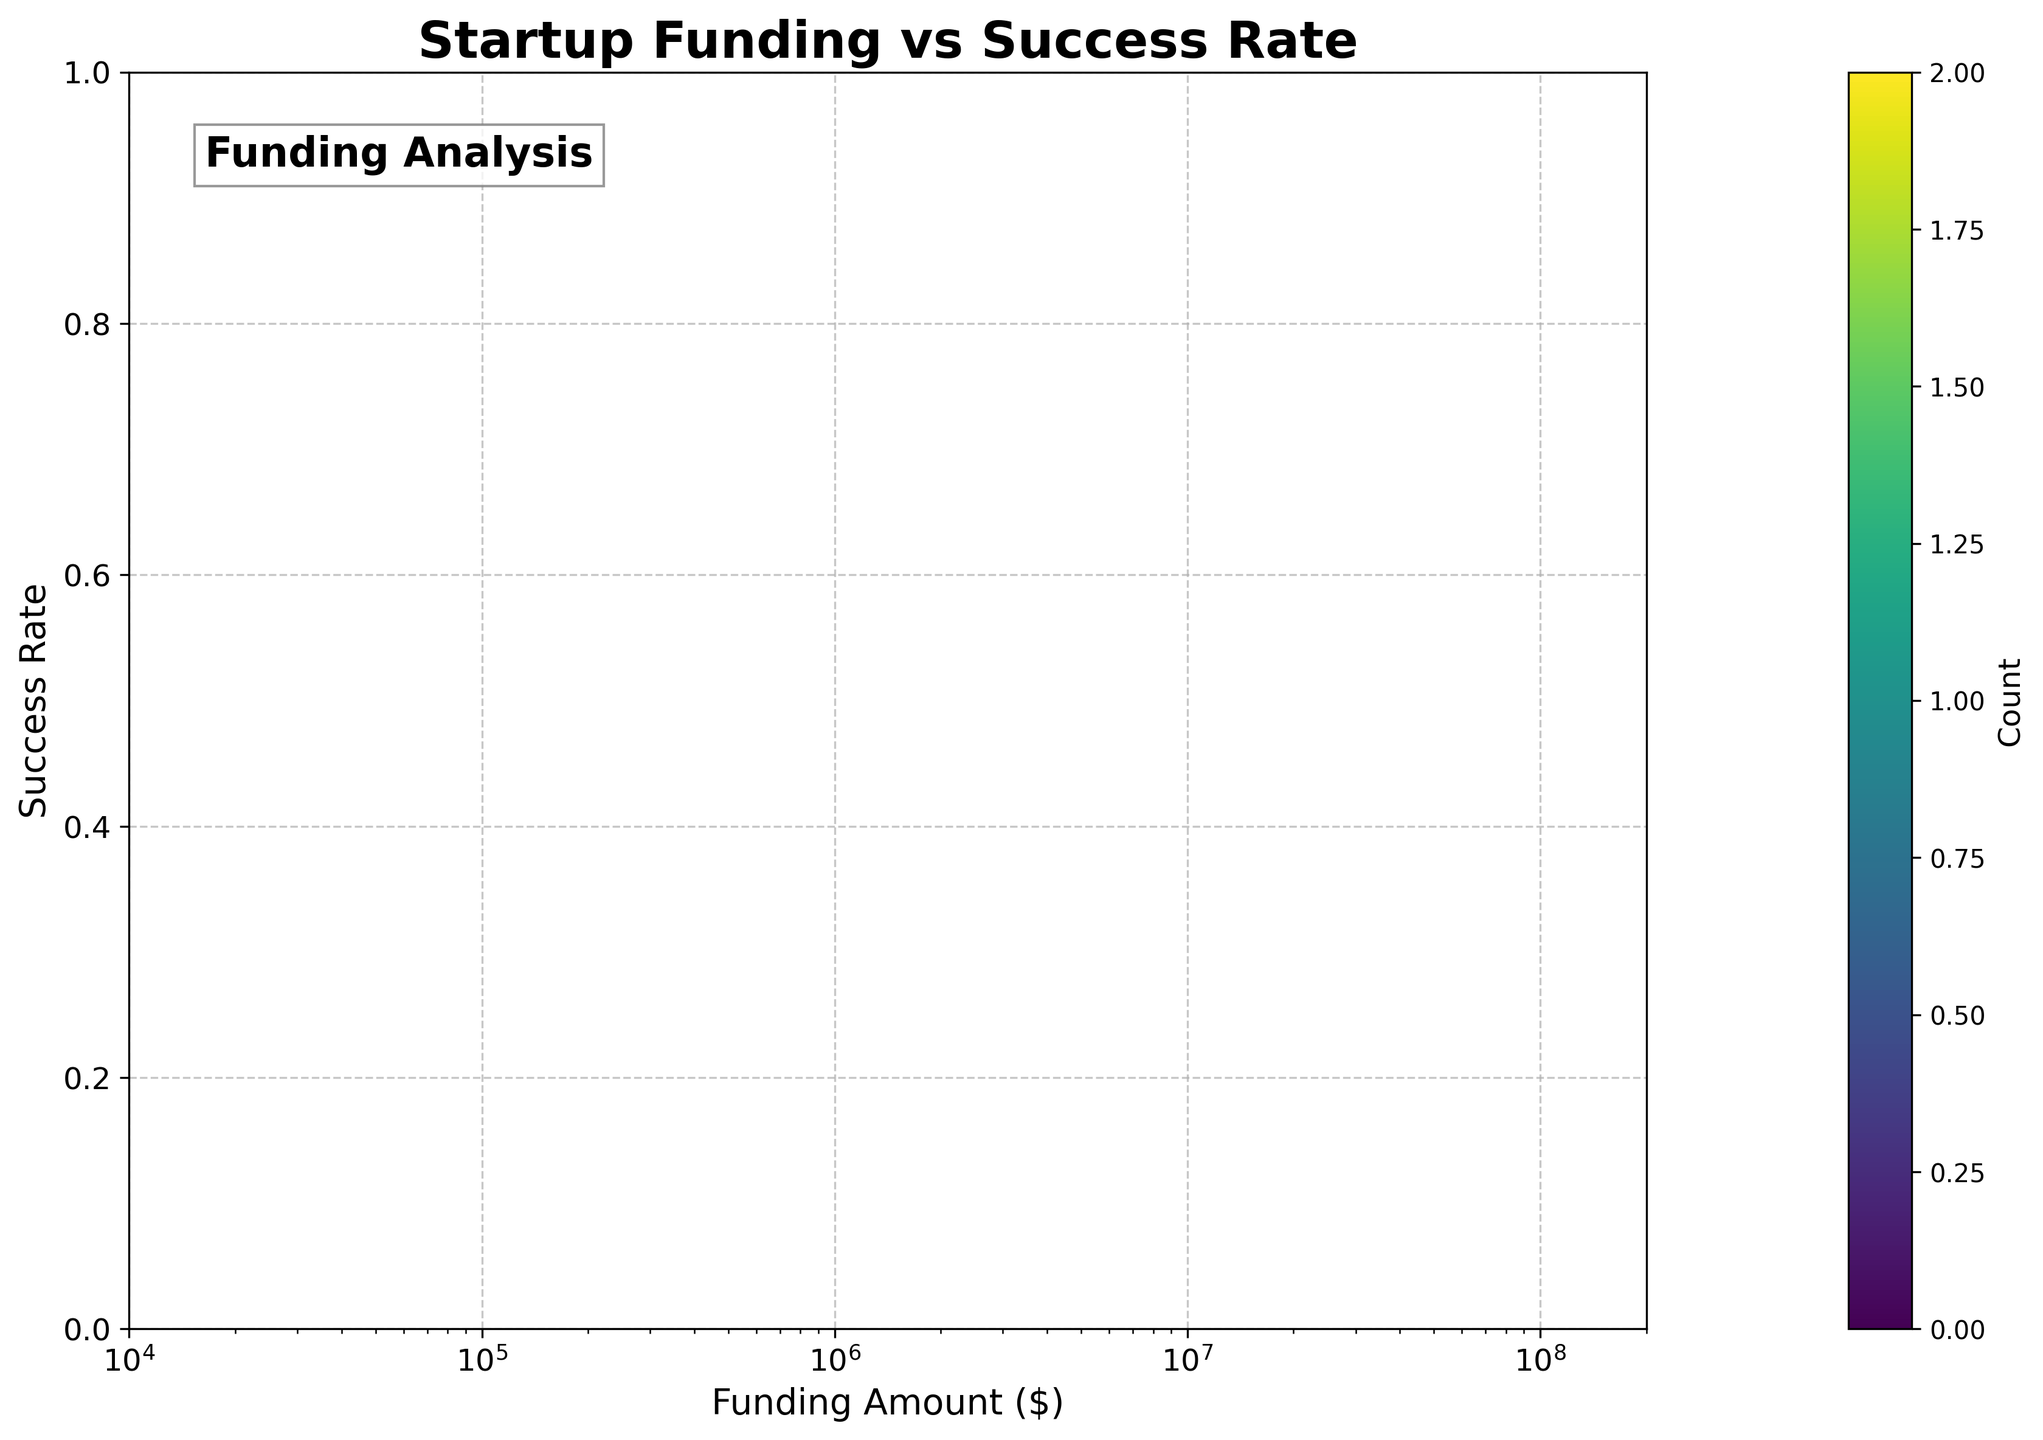What is the title of the figure? The title is typically placed at the top of the figure and provides a description of what the figure represents. In this case, it is "Startup Funding vs Success Rate".
Answer: Startup Funding vs Success Rate What is the scaling method used for the x-axis? The x-axis scale indicates whether the values are represented linearly or logarithmically. Here, the x-axis uses a log scale, which helps in visualizing a wide range of funding amounts compactly.
Answer: Logarithmic What color scheme is used for the hex bins? The color scheme helps in identifying the density of data points within each hex bin. The code specifies the use of 'viridis', which transitions from yellow to dark purple based on density.
Answer: Viridis What range of funding amounts is displayed on the x-axis? The x-axis limits determine the range of values displayed. From the x-axis setup, it is clear the range is from $10,000 to $200,000,000.
Answer: 10,000 to 200,000,000 How many hex bin cells are used in the plot? This question addresses the grid granularity. The plot is generated using a grid size of 15, which determines the number of hexagonal bins across the figure.
Answer: 15 What is the relationship between funding amount and success rate as observed? This requires analyzing the plot overall. Generally, the success rate increases as the funding amount increases, indicated by the upward trend in the hex bins' color gradient.
Answer: Increases How are the hex bins that are close to zero funding amount characterized? Observing the color density of hex bins closest to the lowest funding amounts helps in understanding the distribution. These bins are likely sparse and less dense since the code sets lower ranges for high funding visual differentiation.
Answer: Sparse Is there a maximum success rate observed? By examining the y-axis and the hex bins, we can note that the maximum success rate reaches 0.98.
Answer: 0.98 What can be inferred about the success rate when funding hits the $1,000,000 mark? Observing the point where funding is equal to or slightly above this mark and checking related success bins. The success rate around a $1,000,000 funding amount is roughly 0.65.
Answer: 0.65 Compare the number of projects with funding up to $1,000,000 to those exceeding $1,000,000 in terms of success rate. The comparison requires observing color density on both sides of the $1,000,000 mark. For amounts up to $1,000,000, success rate increases from 0.15 to 0.65, while it continues to rise beyond 0.65 for amounts exceeding $1,000,000.
Answer: Higher beyond $1,000,000 